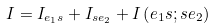<formula> <loc_0><loc_0><loc_500><loc_500>I = I _ { { e _ { 1 } } s } + I _ { s { e _ { 2 } } } + I \left ( { e _ { 1 } } s ; s { e _ { 2 } } \right )</formula> 